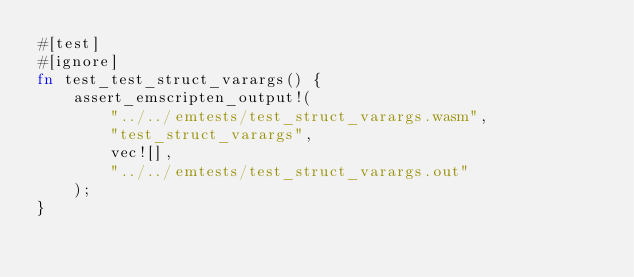Convert code to text. <code><loc_0><loc_0><loc_500><loc_500><_Rust_>#[test]
#[ignore]
fn test_test_struct_varargs() {
    assert_emscripten_output!(
        "../../emtests/test_struct_varargs.wasm",
        "test_struct_varargs",
        vec![],
        "../../emtests/test_struct_varargs.out"
    );
}
</code> 